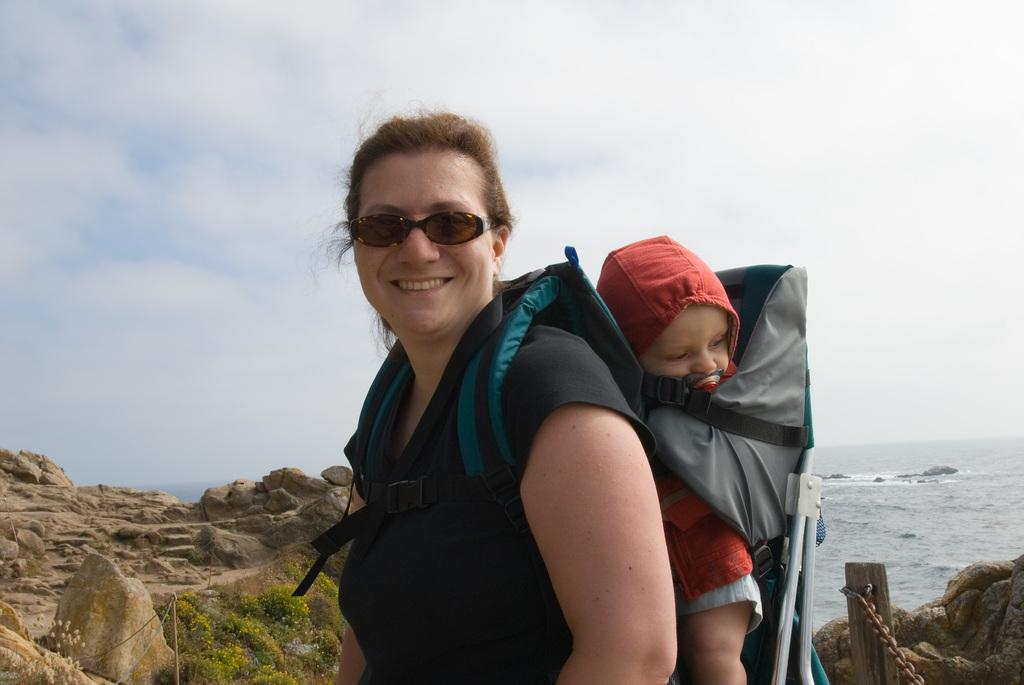Who is the main subject in the image? There is a woman in the image. What is the woman wearing? The woman is wearing a black dress and glasses. What is the woman doing in the image? The woman is carrying a child on her back. What can be seen in the background of the image? There are stones, a fence, water, and a cloudy sky visible in the background. How many boys are flying planes in the image? There are no boys or planes present in the image. What type of marble is visible in the image? There is no marble visible in the image. 